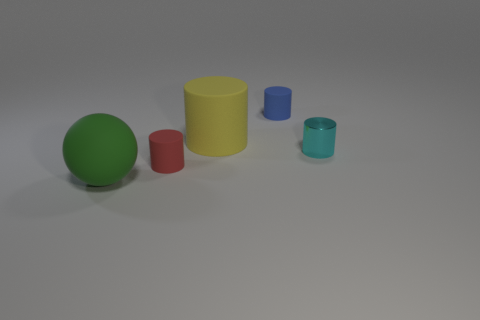Is the shape of the small red thing the same as the rubber thing that is on the left side of the small red thing?
Ensure brevity in your answer.  No. What number of other things are there of the same shape as the blue matte object?
Keep it short and to the point. 3. What number of things are either tiny yellow shiny balls or rubber cylinders?
Your answer should be very brief. 3. Is the color of the big cylinder the same as the tiny metal cylinder?
Make the answer very short. No. Is there anything else that is the same size as the yellow rubber thing?
Provide a succinct answer. Yes. What shape is the big matte object right of the big matte thing that is on the left side of the yellow matte object?
Your response must be concise. Cylinder. Is the number of brown matte cylinders less than the number of big yellow objects?
Your response must be concise. Yes. How big is the rubber thing that is both to the left of the tiny blue matte thing and on the right side of the small red thing?
Keep it short and to the point. Large. Do the blue matte cylinder and the metallic cylinder have the same size?
Your answer should be very brief. Yes. Is the color of the big rubber thing that is to the left of the yellow cylinder the same as the shiny object?
Provide a succinct answer. No. 